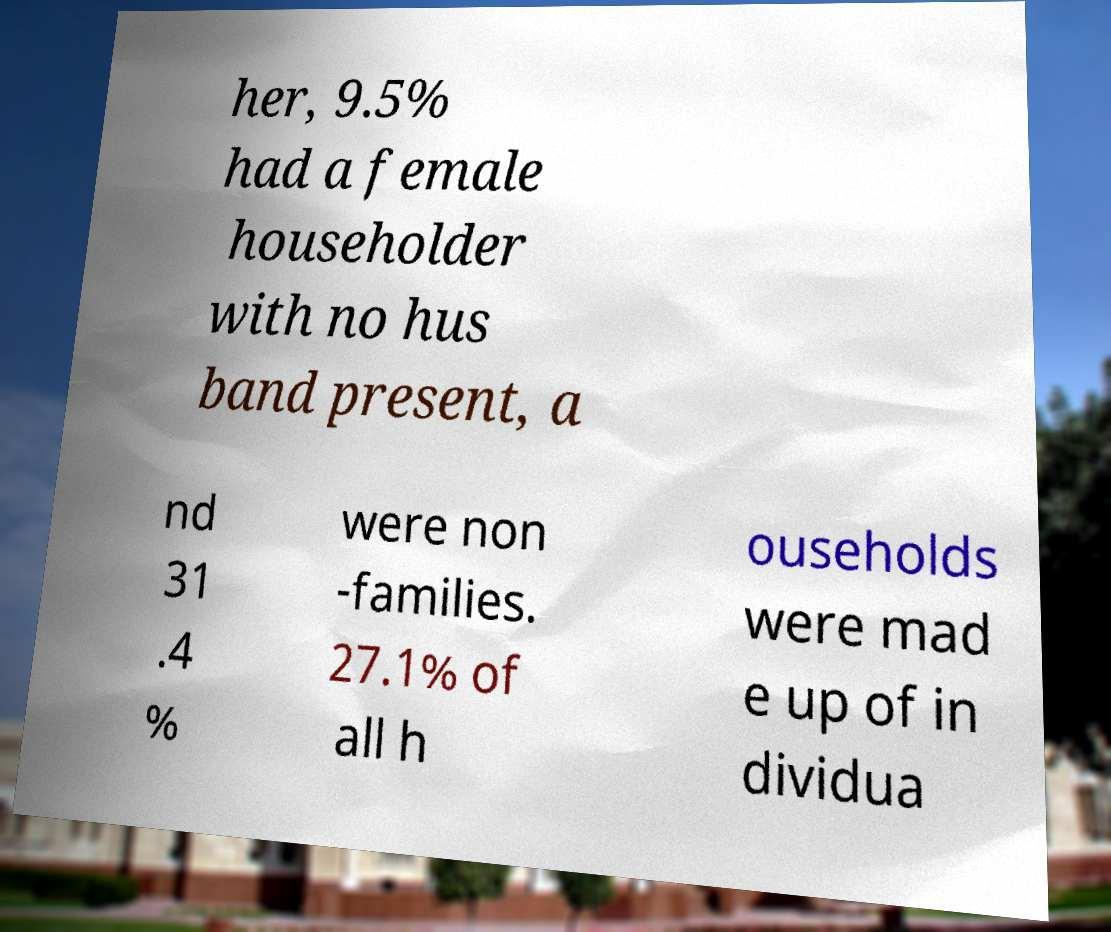Could you assist in decoding the text presented in this image and type it out clearly? her, 9.5% had a female householder with no hus band present, a nd 31 .4 % were non -families. 27.1% of all h ouseholds were mad e up of in dividua 